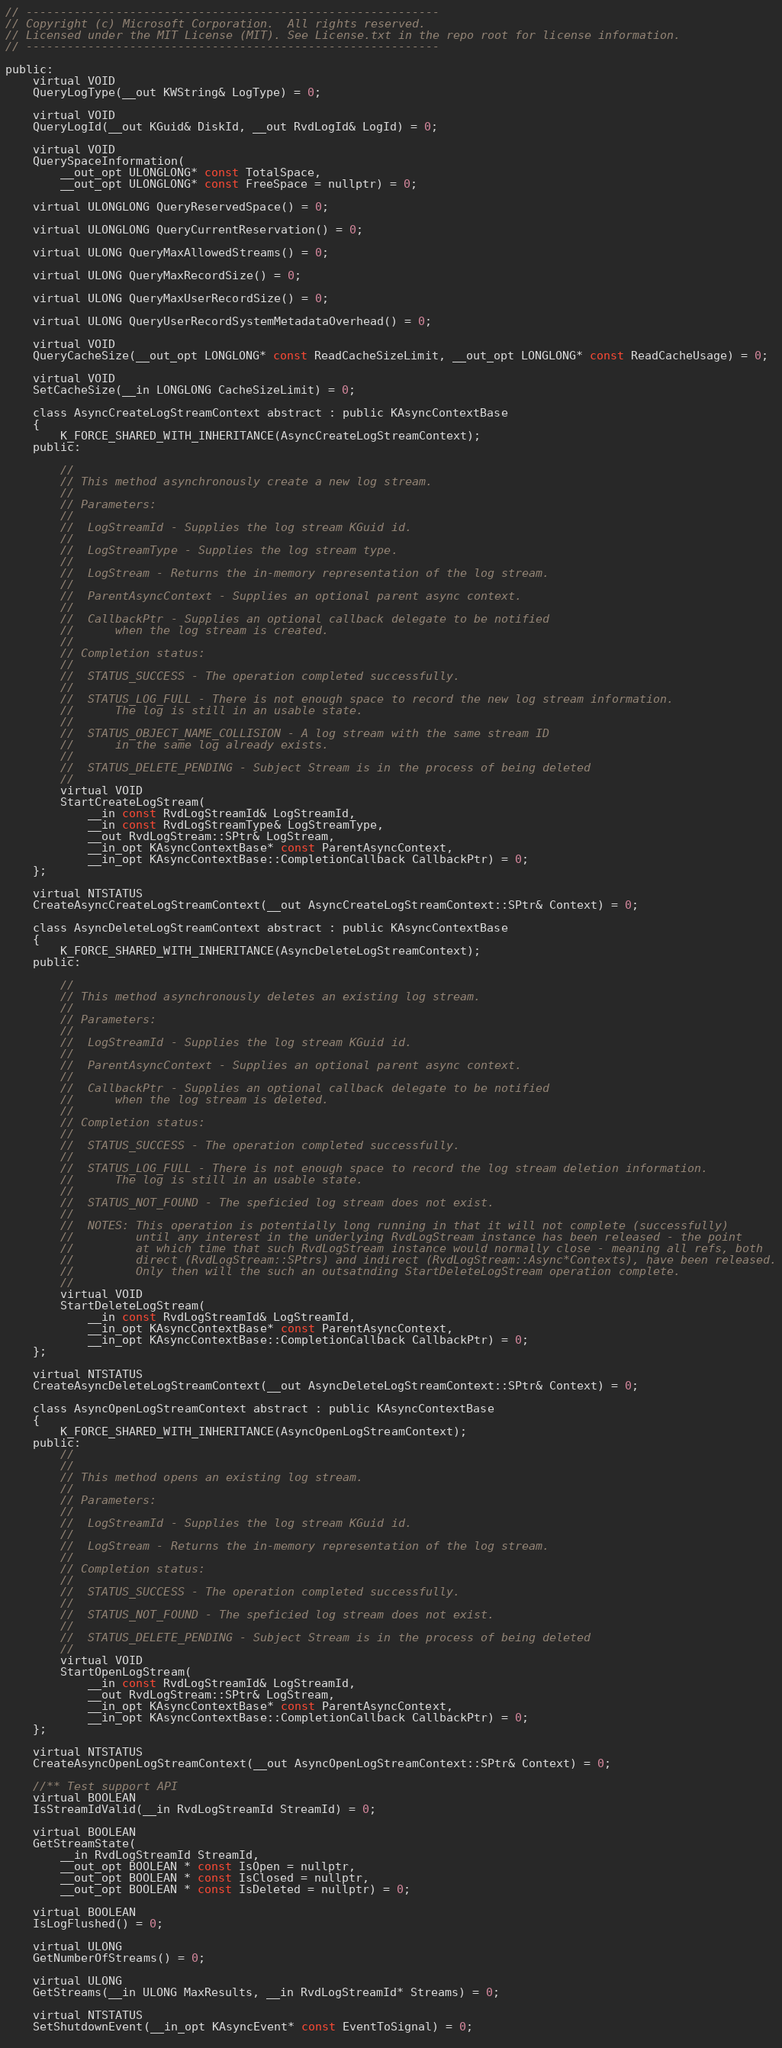Convert code to text. <code><loc_0><loc_0><loc_500><loc_500><_C_>// ------------------------------------------------------------
// Copyright (c) Microsoft Corporation.  All rights reserved.
// Licensed under the MIT License (MIT). See License.txt in the repo root for license information.
// ------------------------------------------------------------

public:
    virtual VOID
    QueryLogType(__out KWString& LogType) = 0;

    virtual VOID
    QueryLogId(__out KGuid& DiskId, __out RvdLogId& LogId) = 0;

    virtual VOID
    QuerySpaceInformation(
        __out_opt ULONGLONG* const TotalSpace,
        __out_opt ULONGLONG* const FreeSpace = nullptr) = 0;

    virtual ULONGLONG QueryReservedSpace() = 0;
	
    virtual ULONGLONG QueryCurrentReservation() = 0;

    virtual ULONG QueryMaxAllowedStreams() = 0;

    virtual ULONG QueryMaxRecordSize() = 0;

    virtual ULONG QueryMaxUserRecordSize() = 0;

    virtual ULONG QueryUserRecordSystemMetadataOverhead() = 0;
	
    virtual VOID
    QueryCacheSize(__out_opt LONGLONG* const ReadCacheSizeLimit, __out_opt LONGLONG* const ReadCacheUsage) = 0;

    virtual VOID
    SetCacheSize(__in LONGLONG CacheSizeLimit) = 0;

    class AsyncCreateLogStreamContext abstract : public KAsyncContextBase
    {
        K_FORCE_SHARED_WITH_INHERITANCE(AsyncCreateLogStreamContext);
    public:

        //
        // This method asynchronously create a new log stream.
        //
        // Parameters:
        //
        //  LogStreamId - Supplies the log stream KGuid id.
        //
        //  LogStreamType - Supplies the log stream type.
        //
        //  LogStream - Returns the in-memory representation of the log stream.
        //
        //  ParentAsyncContext - Supplies an optional parent async context.
        //
        //  CallbackPtr - Supplies an optional callback delegate to be notified
        //      when the log stream is created.
        //
        // Completion status:
        //
        //  STATUS_SUCCESS - The operation completed successfully.
        //
        //  STATUS_LOG_FULL - There is not enough space to record the new log stream information.
        //      The log is still in an usable state.
        //
        //  STATUS_OBJECT_NAME_COLLISION - A log stream with the same stream ID
        //      in the same log already exists.
        //
        //  STATUS_DELETE_PENDING - Subject Stream is in the process of being deleted
        //
        virtual VOID
        StartCreateLogStream(
            __in const RvdLogStreamId& LogStreamId,
            __in const RvdLogStreamType& LogStreamType,
            __out RvdLogStream::SPtr& LogStream,
            __in_opt KAsyncContextBase* const ParentAsyncContext,
            __in_opt KAsyncContextBase::CompletionCallback CallbackPtr) = 0;
    };

    virtual NTSTATUS
    CreateAsyncCreateLogStreamContext(__out AsyncCreateLogStreamContext::SPtr& Context) = 0;

    class AsyncDeleteLogStreamContext abstract : public KAsyncContextBase
    {
        K_FORCE_SHARED_WITH_INHERITANCE(AsyncDeleteLogStreamContext);
    public:

        //
        // This method asynchronously deletes an existing log stream.
        //
        // Parameters:
        //
        //  LogStreamId - Supplies the log stream KGuid id.
        //
        //  ParentAsyncContext - Supplies an optional parent async context.
        //
        //  CallbackPtr - Supplies an optional callback delegate to be notified
        //      when the log stream is deleted.
        //
        // Completion status:
        //
        //  STATUS_SUCCESS - The operation completed successfully.
        //
        //  STATUS_LOG_FULL - There is not enough space to record the log stream deletion information.
        //      The log is still in an usable state.
        //
        //  STATUS_NOT_FOUND - The speficied log stream does not exist.
        //
        //  NOTES: This operation is potentially long running in that it will not complete (successfully)
        //         until any interest in the underlying RvdLogStream instance has been released - the point
        //         at which time that such RvdLogStream instance would normally close - meaning all refs, both
        //         direct (RvdLogStream::SPtrs) and indirect (RvdLogStream::Async*Contexts), have been released.
        //         Only then will the such an outsatnding StartDeleteLogStream operation complete.
        //
        virtual VOID
        StartDeleteLogStream(
            __in const RvdLogStreamId& LogStreamId,
            __in_opt KAsyncContextBase* const ParentAsyncContext,
            __in_opt KAsyncContextBase::CompletionCallback CallbackPtr) = 0;
    };

    virtual NTSTATUS
    CreateAsyncDeleteLogStreamContext(__out AsyncDeleteLogStreamContext::SPtr& Context) = 0;

    class AsyncOpenLogStreamContext abstract : public KAsyncContextBase
    {
        K_FORCE_SHARED_WITH_INHERITANCE(AsyncOpenLogStreamContext);
    public:
        //
        //
        // This method opens an existing log stream.
        //
        // Parameters:
        //
        //  LogStreamId - Supplies the log stream KGuid id.
        //
        //  LogStream - Returns the in-memory representation of the log stream.
        //
        // Completion status:
        //
        //  STATUS_SUCCESS - The operation completed successfully.
        //
        //  STATUS_NOT_FOUND - The speficied log stream does not exist.
        //
        //  STATUS_DELETE_PENDING - Subject Stream is in the process of being deleted
        //
        virtual VOID
        StartOpenLogStream(
            __in const RvdLogStreamId& LogStreamId,
            __out RvdLogStream::SPtr& LogStream,
            __in_opt KAsyncContextBase* const ParentAsyncContext,
            __in_opt KAsyncContextBase::CompletionCallback CallbackPtr) = 0;
    };

    virtual NTSTATUS
    CreateAsyncOpenLogStreamContext(__out AsyncOpenLogStreamContext::SPtr& Context) = 0;

    //** Test support API
    virtual BOOLEAN
    IsStreamIdValid(__in RvdLogStreamId StreamId) = 0;

    virtual BOOLEAN
    GetStreamState(
        __in RvdLogStreamId StreamId,
        __out_opt BOOLEAN * const IsOpen = nullptr,
        __out_opt BOOLEAN * const IsClosed = nullptr,
        __out_opt BOOLEAN * const IsDeleted = nullptr) = 0;

    virtual BOOLEAN
    IsLogFlushed() = 0;

    virtual ULONG
    GetNumberOfStreams() = 0;

    virtual ULONG
    GetStreams(__in ULONG MaxResults, __in RvdLogStreamId* Streams) = 0;

    virtual NTSTATUS
    SetShutdownEvent(__in_opt KAsyncEvent* const EventToSignal) = 0;
	
</code> 